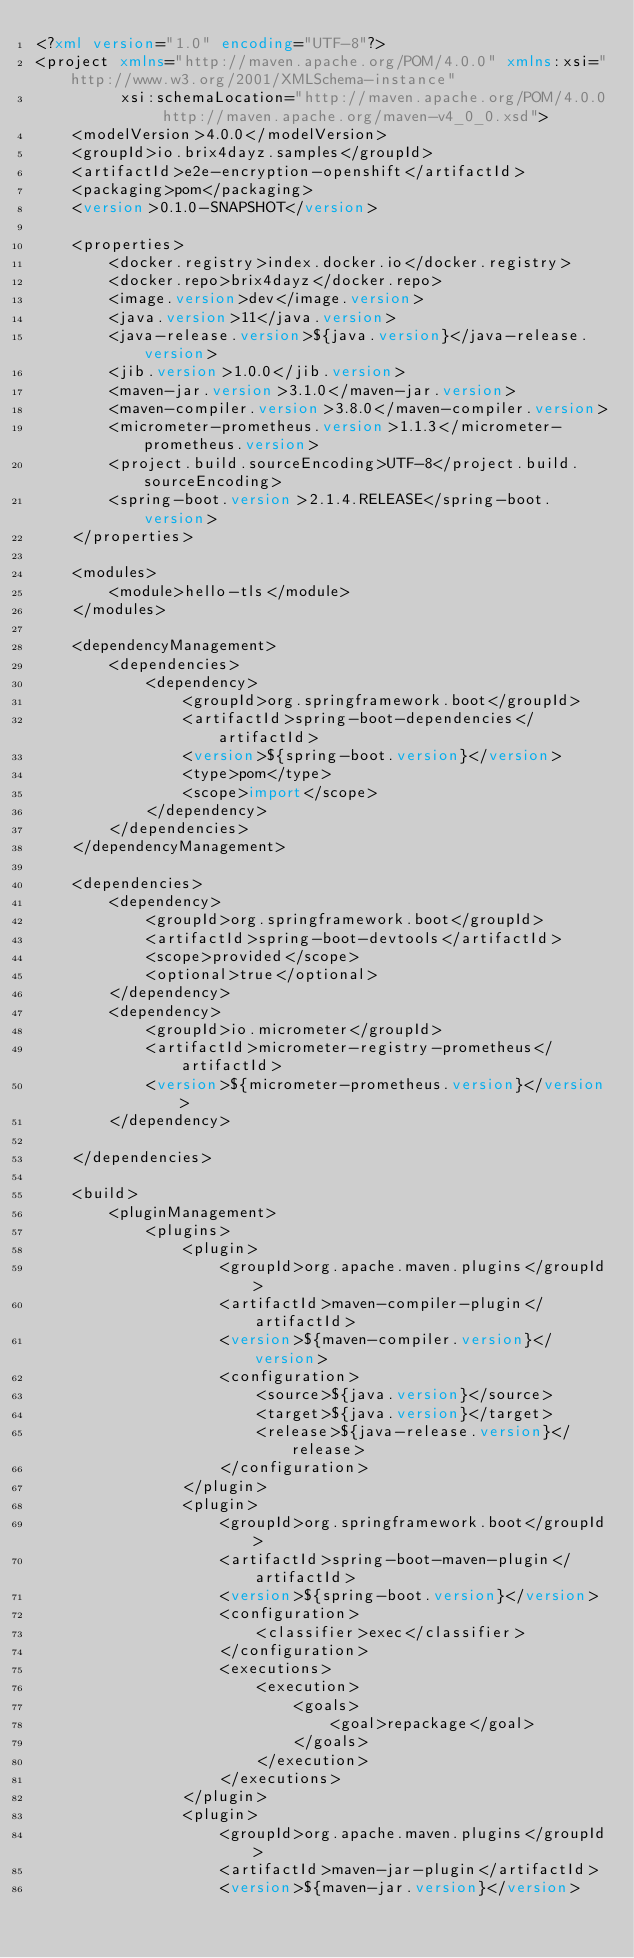Convert code to text. <code><loc_0><loc_0><loc_500><loc_500><_XML_><?xml version="1.0" encoding="UTF-8"?>
<project xmlns="http://maven.apache.org/POM/4.0.0" xmlns:xsi="http://www.w3.org/2001/XMLSchema-instance"
         xsi:schemaLocation="http://maven.apache.org/POM/4.0.0 http://maven.apache.org/maven-v4_0_0.xsd">
    <modelVersion>4.0.0</modelVersion>
    <groupId>io.brix4dayz.samples</groupId>
    <artifactId>e2e-encryption-openshift</artifactId>
    <packaging>pom</packaging>
    <version>0.1.0-SNAPSHOT</version>

    <properties>
        <docker.registry>index.docker.io</docker.registry>
        <docker.repo>brix4dayz</docker.repo>
        <image.version>dev</image.version>
        <java.version>11</java.version>
        <java-release.version>${java.version}</java-release.version>
        <jib.version>1.0.0</jib.version>
        <maven-jar.version>3.1.0</maven-jar.version>
        <maven-compiler.version>3.8.0</maven-compiler.version>
        <micrometer-prometheus.version>1.1.3</micrometer-prometheus.version>
        <project.build.sourceEncoding>UTF-8</project.build.sourceEncoding>
        <spring-boot.version>2.1.4.RELEASE</spring-boot.version>
    </properties>

    <modules>
        <module>hello-tls</module>
    </modules>

    <dependencyManagement>
        <dependencies>
            <dependency>
                <groupId>org.springframework.boot</groupId>
                <artifactId>spring-boot-dependencies</artifactId>
                <version>${spring-boot.version}</version>
                <type>pom</type>
                <scope>import</scope>
            </dependency>
        </dependencies>
    </dependencyManagement>

    <dependencies>
        <dependency>
            <groupId>org.springframework.boot</groupId>
            <artifactId>spring-boot-devtools</artifactId>
            <scope>provided</scope>
            <optional>true</optional>
        </dependency>
        <dependency>
            <groupId>io.micrometer</groupId>
            <artifactId>micrometer-registry-prometheus</artifactId>
            <version>${micrometer-prometheus.version}</version>
        </dependency>

    </dependencies>

    <build>
        <pluginManagement>
            <plugins>
                <plugin>
                    <groupId>org.apache.maven.plugins</groupId>
                    <artifactId>maven-compiler-plugin</artifactId>
                    <version>${maven-compiler.version}</version>
                    <configuration>
                        <source>${java.version}</source>
                        <target>${java.version}</target>
                        <release>${java-release.version}</release>
                    </configuration>
                </plugin>
                <plugin>
                    <groupId>org.springframework.boot</groupId>
                    <artifactId>spring-boot-maven-plugin</artifactId>
                    <version>${spring-boot.version}</version>
                    <configuration>
                        <classifier>exec</classifier>
                    </configuration>
                    <executions>
                        <execution>
                            <goals>
                                <goal>repackage</goal>
                            </goals>
                        </execution>
                    </executions>
                </plugin>
                <plugin>
                    <groupId>org.apache.maven.plugins</groupId>
                    <artifactId>maven-jar-plugin</artifactId>
                    <version>${maven-jar.version}</version></code> 